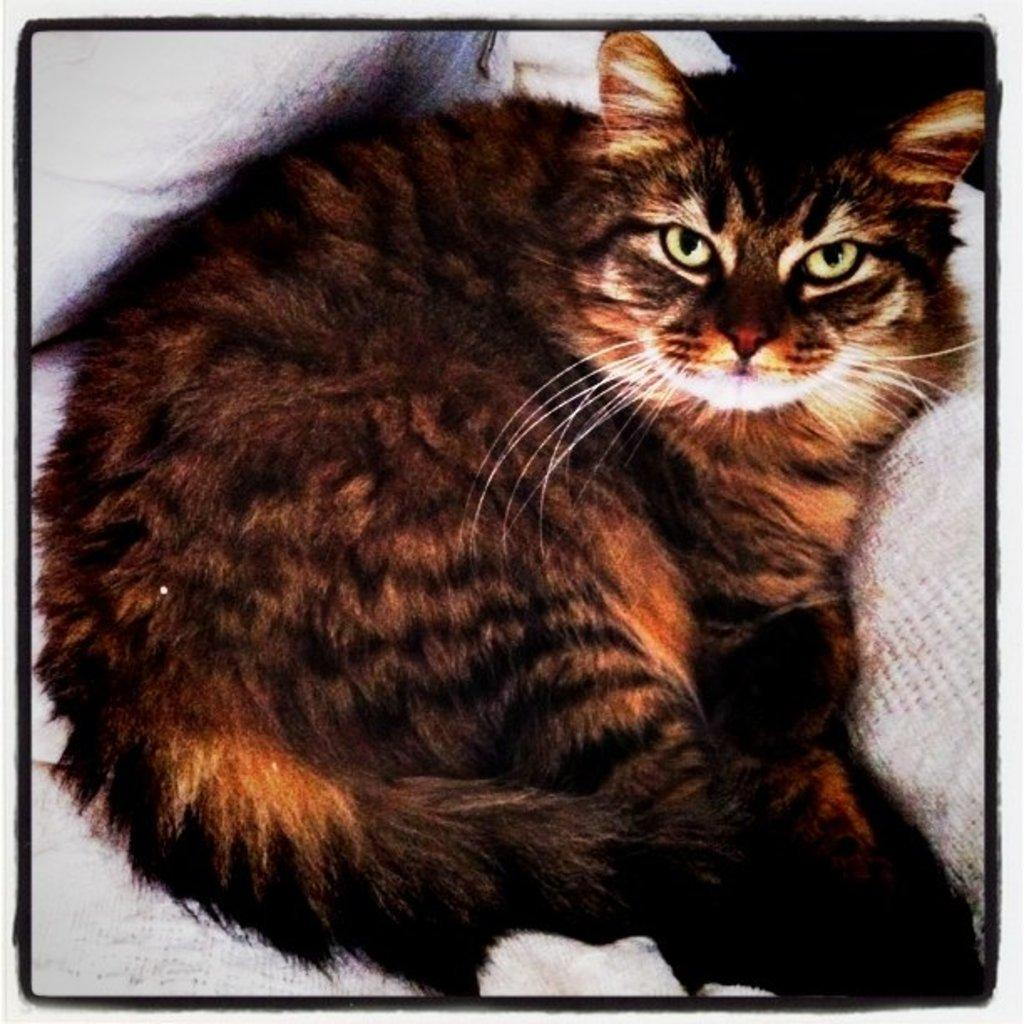What type of animal is present in the image? There is a cat in the image. What is the cat doing in the image? The cat is lying on an object. What type of fabric is the cat using as a blanket in the image? There is no fabric or blanket mentioned in the image; the cat is simply lying on an object. 